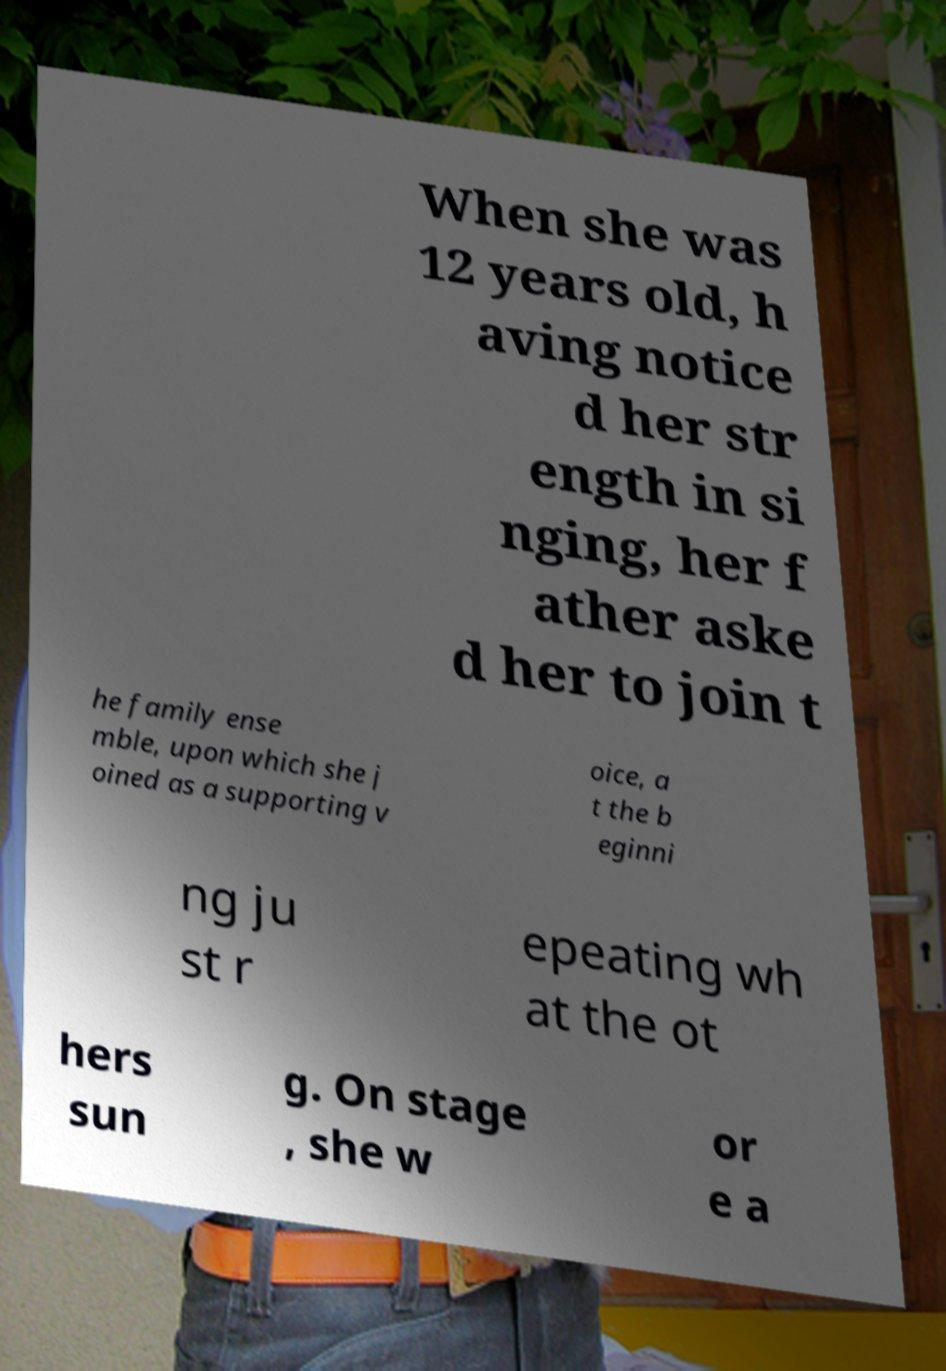Could you extract and type out the text from this image? When she was 12 years old, h aving notice d her str ength in si nging, her f ather aske d her to join t he family ense mble, upon which she j oined as a supporting v oice, a t the b eginni ng ju st r epeating wh at the ot hers sun g. On stage , she w or e a 